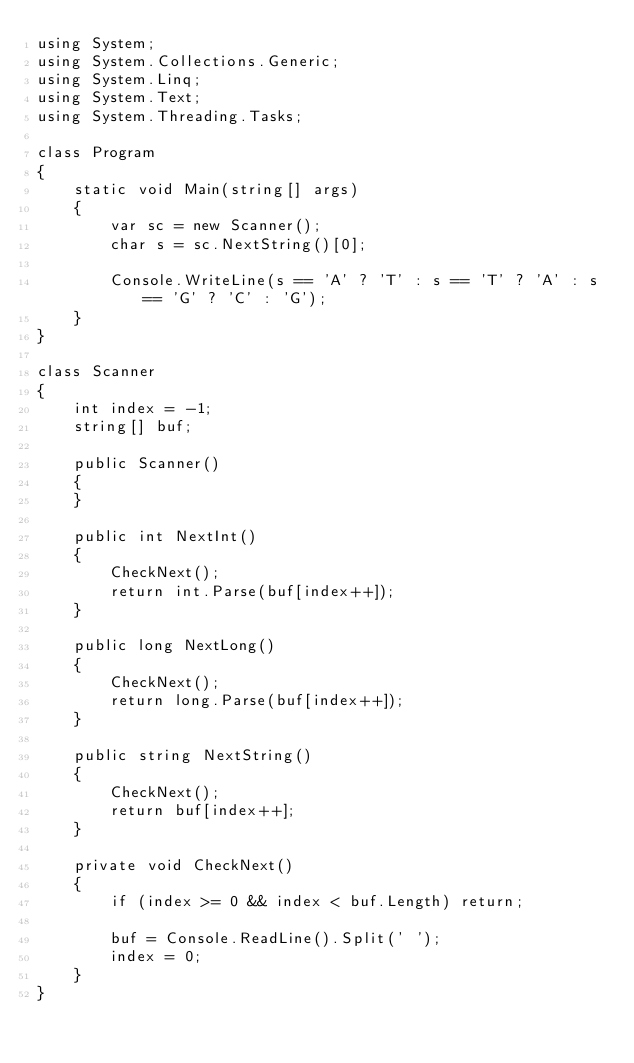Convert code to text. <code><loc_0><loc_0><loc_500><loc_500><_C#_>using System;
using System.Collections.Generic;
using System.Linq;
using System.Text;
using System.Threading.Tasks;

class Program
{
    static void Main(string[] args)
    {
        var sc = new Scanner();
        char s = sc.NextString()[0];
        
        Console.WriteLine(s == 'A' ? 'T' : s == 'T' ? 'A' : s == 'G' ? 'C' : 'G');
    }
}

class Scanner
{
    int index = -1;
    string[] buf;

    public Scanner()
    {
    }

    public int NextInt()
    {
        CheckNext();
        return int.Parse(buf[index++]);
    }
        
    public long NextLong()
    {
    	CheckNext();
    	return long.Parse(buf[index++]);
    }

    public string NextString()
    {
        CheckNext();
        return buf[index++];
    }

    private void CheckNext()
    {
        if (index >= 0 && index < buf.Length) return;

        buf = Console.ReadLine().Split(' ');
        index = 0;
    }
}</code> 